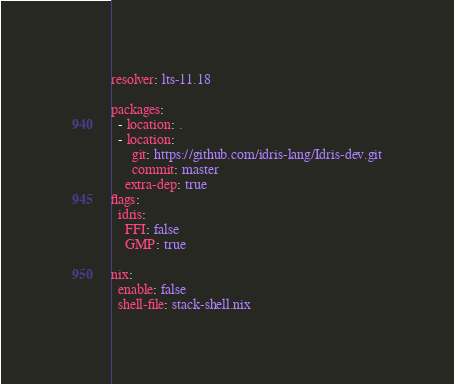Convert code to text. <code><loc_0><loc_0><loc_500><loc_500><_YAML_>resolver: lts-11.18

packages:
  - location: .
  - location:
      git: https://github.com/idris-lang/Idris-dev.git
      commit: master
    extra-dep: true
flags:
  idris:
    FFI: false
    GMP: true

nix:
  enable: false
  shell-file: stack-shell.nix
</code> 